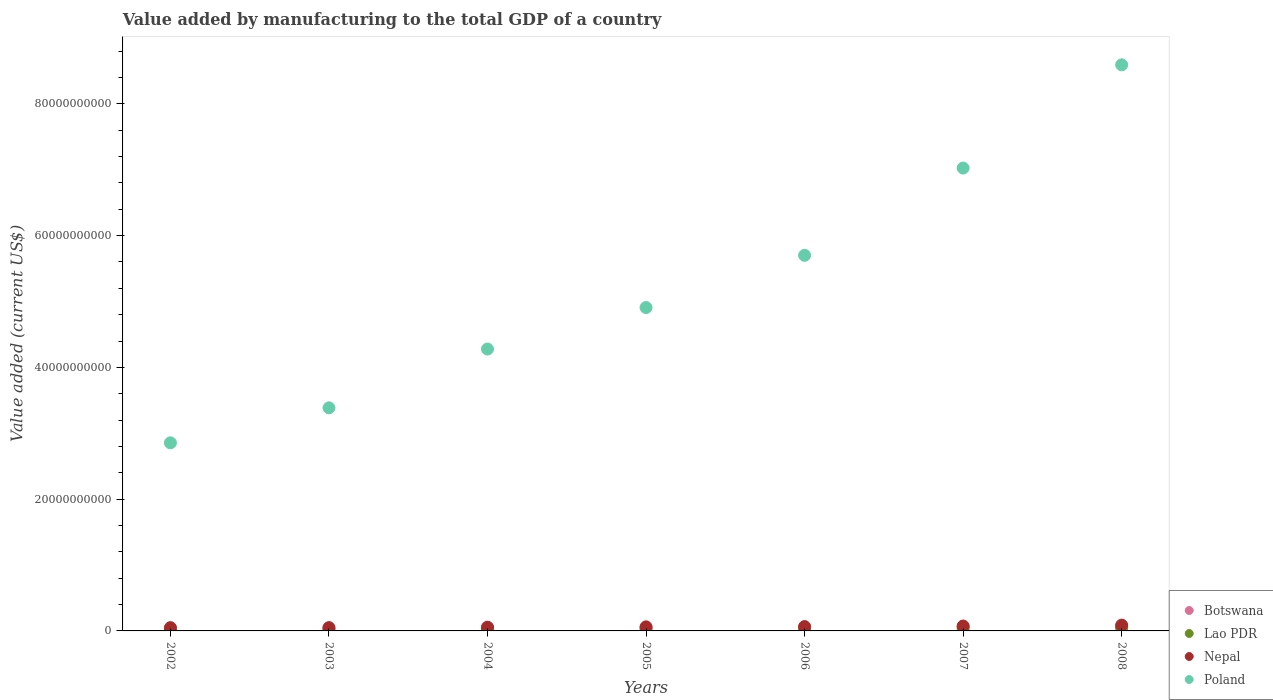How many different coloured dotlines are there?
Keep it short and to the point. 4. Is the number of dotlines equal to the number of legend labels?
Provide a short and direct response. Yes. What is the value added by manufacturing to the total GDP in Lao PDR in 2002?
Ensure brevity in your answer.  1.49e+08. Across all years, what is the maximum value added by manufacturing to the total GDP in Botswana?
Your answer should be compact. 6.85e+08. Across all years, what is the minimum value added by manufacturing to the total GDP in Nepal?
Offer a terse response. 4.97e+08. What is the total value added by manufacturing to the total GDP in Poland in the graph?
Ensure brevity in your answer.  3.67e+11. What is the difference between the value added by manufacturing to the total GDP in Lao PDR in 2002 and that in 2004?
Make the answer very short. -5.04e+07. What is the difference between the value added by manufacturing to the total GDP in Botswana in 2005 and the value added by manufacturing to the total GDP in Poland in 2007?
Your response must be concise. -6.98e+1. What is the average value added by manufacturing to the total GDP in Nepal per year?
Your response must be concise. 6.37e+08. In the year 2005, what is the difference between the value added by manufacturing to the total GDP in Botswana and value added by manufacturing to the total GDP in Nepal?
Offer a terse response. -1.28e+08. In how many years, is the value added by manufacturing to the total GDP in Nepal greater than 8000000000 US$?
Offer a very short reply. 0. What is the ratio of the value added by manufacturing to the total GDP in Nepal in 2005 to that in 2008?
Give a very brief answer. 0.7. What is the difference between the highest and the second highest value added by manufacturing to the total GDP in Lao PDR?
Your answer should be compact. 1.13e+08. What is the difference between the highest and the lowest value added by manufacturing to the total GDP in Lao PDR?
Make the answer very short. 3.08e+08. Is it the case that in every year, the sum of the value added by manufacturing to the total GDP in Botswana and value added by manufacturing to the total GDP in Lao PDR  is greater than the sum of value added by manufacturing to the total GDP in Poland and value added by manufacturing to the total GDP in Nepal?
Provide a short and direct response. No. Is it the case that in every year, the sum of the value added by manufacturing to the total GDP in Lao PDR and value added by manufacturing to the total GDP in Poland  is greater than the value added by manufacturing to the total GDP in Nepal?
Offer a terse response. Yes. Is the value added by manufacturing to the total GDP in Nepal strictly less than the value added by manufacturing to the total GDP in Lao PDR over the years?
Provide a succinct answer. No. How many years are there in the graph?
Your answer should be compact. 7. What is the difference between two consecutive major ticks on the Y-axis?
Provide a succinct answer. 2.00e+1. Does the graph contain any zero values?
Make the answer very short. No. What is the title of the graph?
Ensure brevity in your answer.  Value added by manufacturing to the total GDP of a country. Does "Kazakhstan" appear as one of the legend labels in the graph?
Provide a succinct answer. No. What is the label or title of the Y-axis?
Keep it short and to the point. Value added (current US$). What is the Value added (current US$) of Botswana in 2002?
Your answer should be compact. 3.29e+08. What is the Value added (current US$) of Lao PDR in 2002?
Offer a terse response. 1.49e+08. What is the Value added (current US$) of Nepal in 2002?
Your answer should be compact. 4.97e+08. What is the Value added (current US$) in Poland in 2002?
Your answer should be very brief. 2.85e+1. What is the Value added (current US$) in Botswana in 2003?
Provide a short and direct response. 4.29e+08. What is the Value added (current US$) of Lao PDR in 2003?
Provide a short and direct response. 1.65e+08. What is the Value added (current US$) of Nepal in 2003?
Provide a short and direct response. 4.99e+08. What is the Value added (current US$) in Poland in 2003?
Give a very brief answer. 3.39e+1. What is the Value added (current US$) in Botswana in 2004?
Offer a very short reply. 4.98e+08. What is the Value added (current US$) of Lao PDR in 2004?
Your response must be concise. 1.99e+08. What is the Value added (current US$) in Nepal in 2004?
Provide a succinct answer. 5.65e+08. What is the Value added (current US$) in Poland in 2004?
Your answer should be very brief. 4.28e+1. What is the Value added (current US$) in Botswana in 2005?
Make the answer very short. 4.92e+08. What is the Value added (current US$) in Lao PDR in 2005?
Provide a succinct answer. 2.57e+08. What is the Value added (current US$) of Nepal in 2005?
Offer a very short reply. 6.19e+08. What is the Value added (current US$) in Poland in 2005?
Make the answer very short. 4.91e+1. What is the Value added (current US$) in Botswana in 2006?
Your response must be concise. 5.35e+08. What is the Value added (current US$) in Lao PDR in 2006?
Make the answer very short. 2.73e+08. What is the Value added (current US$) in Nepal in 2006?
Offer a very short reply. 6.61e+08. What is the Value added (current US$) in Poland in 2006?
Your response must be concise. 5.70e+1. What is the Value added (current US$) of Botswana in 2007?
Give a very brief answer. 6.85e+08. What is the Value added (current US$) of Lao PDR in 2007?
Offer a terse response. 3.44e+08. What is the Value added (current US$) in Nepal in 2007?
Ensure brevity in your answer.  7.40e+08. What is the Value added (current US$) of Poland in 2007?
Keep it short and to the point. 7.03e+1. What is the Value added (current US$) in Botswana in 2008?
Your response must be concise. 6.27e+08. What is the Value added (current US$) of Lao PDR in 2008?
Provide a succinct answer. 4.56e+08. What is the Value added (current US$) of Nepal in 2008?
Give a very brief answer. 8.80e+08. What is the Value added (current US$) of Poland in 2008?
Your response must be concise. 8.59e+1. Across all years, what is the maximum Value added (current US$) of Botswana?
Your answer should be compact. 6.85e+08. Across all years, what is the maximum Value added (current US$) of Lao PDR?
Your answer should be very brief. 4.56e+08. Across all years, what is the maximum Value added (current US$) in Nepal?
Provide a short and direct response. 8.80e+08. Across all years, what is the maximum Value added (current US$) in Poland?
Offer a terse response. 8.59e+1. Across all years, what is the minimum Value added (current US$) in Botswana?
Offer a very short reply. 3.29e+08. Across all years, what is the minimum Value added (current US$) in Lao PDR?
Your answer should be compact. 1.49e+08. Across all years, what is the minimum Value added (current US$) of Nepal?
Ensure brevity in your answer.  4.97e+08. Across all years, what is the minimum Value added (current US$) in Poland?
Give a very brief answer. 2.85e+1. What is the total Value added (current US$) of Botswana in the graph?
Provide a short and direct response. 3.59e+09. What is the total Value added (current US$) in Lao PDR in the graph?
Make the answer very short. 1.84e+09. What is the total Value added (current US$) of Nepal in the graph?
Provide a succinct answer. 4.46e+09. What is the total Value added (current US$) of Poland in the graph?
Ensure brevity in your answer.  3.67e+11. What is the difference between the Value added (current US$) in Botswana in 2002 and that in 2003?
Make the answer very short. -9.91e+07. What is the difference between the Value added (current US$) in Lao PDR in 2002 and that in 2003?
Ensure brevity in your answer.  -1.67e+07. What is the difference between the Value added (current US$) of Nepal in 2002 and that in 2003?
Make the answer very short. -2.35e+06. What is the difference between the Value added (current US$) in Poland in 2002 and that in 2003?
Your response must be concise. -5.31e+09. What is the difference between the Value added (current US$) in Botswana in 2002 and that in 2004?
Ensure brevity in your answer.  -1.68e+08. What is the difference between the Value added (current US$) in Lao PDR in 2002 and that in 2004?
Provide a succinct answer. -5.04e+07. What is the difference between the Value added (current US$) in Nepal in 2002 and that in 2004?
Offer a terse response. -6.78e+07. What is the difference between the Value added (current US$) in Poland in 2002 and that in 2004?
Provide a succinct answer. -1.42e+1. What is the difference between the Value added (current US$) of Botswana in 2002 and that in 2005?
Keep it short and to the point. -1.62e+08. What is the difference between the Value added (current US$) of Lao PDR in 2002 and that in 2005?
Give a very brief answer. -1.08e+08. What is the difference between the Value added (current US$) in Nepal in 2002 and that in 2005?
Ensure brevity in your answer.  -1.22e+08. What is the difference between the Value added (current US$) of Poland in 2002 and that in 2005?
Offer a very short reply. -2.05e+1. What is the difference between the Value added (current US$) in Botswana in 2002 and that in 2006?
Give a very brief answer. -2.06e+08. What is the difference between the Value added (current US$) of Lao PDR in 2002 and that in 2006?
Offer a very short reply. -1.25e+08. What is the difference between the Value added (current US$) in Nepal in 2002 and that in 2006?
Your answer should be compact. -1.64e+08. What is the difference between the Value added (current US$) of Poland in 2002 and that in 2006?
Your answer should be compact. -2.85e+1. What is the difference between the Value added (current US$) of Botswana in 2002 and that in 2007?
Give a very brief answer. -3.56e+08. What is the difference between the Value added (current US$) of Lao PDR in 2002 and that in 2007?
Ensure brevity in your answer.  -1.95e+08. What is the difference between the Value added (current US$) in Nepal in 2002 and that in 2007?
Your answer should be compact. -2.43e+08. What is the difference between the Value added (current US$) in Poland in 2002 and that in 2007?
Offer a terse response. -4.17e+1. What is the difference between the Value added (current US$) in Botswana in 2002 and that in 2008?
Ensure brevity in your answer.  -2.97e+08. What is the difference between the Value added (current US$) in Lao PDR in 2002 and that in 2008?
Provide a short and direct response. -3.08e+08. What is the difference between the Value added (current US$) in Nepal in 2002 and that in 2008?
Your answer should be compact. -3.83e+08. What is the difference between the Value added (current US$) in Poland in 2002 and that in 2008?
Ensure brevity in your answer.  -5.74e+1. What is the difference between the Value added (current US$) of Botswana in 2003 and that in 2004?
Keep it short and to the point. -6.89e+07. What is the difference between the Value added (current US$) in Lao PDR in 2003 and that in 2004?
Provide a succinct answer. -3.37e+07. What is the difference between the Value added (current US$) of Nepal in 2003 and that in 2004?
Give a very brief answer. -6.54e+07. What is the difference between the Value added (current US$) in Poland in 2003 and that in 2004?
Keep it short and to the point. -8.92e+09. What is the difference between the Value added (current US$) in Botswana in 2003 and that in 2005?
Your answer should be compact. -6.30e+07. What is the difference between the Value added (current US$) of Lao PDR in 2003 and that in 2005?
Make the answer very short. -9.12e+07. What is the difference between the Value added (current US$) of Nepal in 2003 and that in 2005?
Provide a short and direct response. -1.20e+08. What is the difference between the Value added (current US$) of Poland in 2003 and that in 2005?
Offer a very short reply. -1.52e+1. What is the difference between the Value added (current US$) of Botswana in 2003 and that in 2006?
Your answer should be compact. -1.07e+08. What is the difference between the Value added (current US$) of Lao PDR in 2003 and that in 2006?
Make the answer very short. -1.08e+08. What is the difference between the Value added (current US$) in Nepal in 2003 and that in 2006?
Your response must be concise. -1.62e+08. What is the difference between the Value added (current US$) of Poland in 2003 and that in 2006?
Offer a very short reply. -2.31e+1. What is the difference between the Value added (current US$) in Botswana in 2003 and that in 2007?
Offer a terse response. -2.57e+08. What is the difference between the Value added (current US$) of Lao PDR in 2003 and that in 2007?
Your response must be concise. -1.79e+08. What is the difference between the Value added (current US$) of Nepal in 2003 and that in 2007?
Your response must be concise. -2.41e+08. What is the difference between the Value added (current US$) in Poland in 2003 and that in 2007?
Provide a short and direct response. -3.64e+1. What is the difference between the Value added (current US$) of Botswana in 2003 and that in 2008?
Your response must be concise. -1.98e+08. What is the difference between the Value added (current US$) of Lao PDR in 2003 and that in 2008?
Offer a terse response. -2.91e+08. What is the difference between the Value added (current US$) in Nepal in 2003 and that in 2008?
Ensure brevity in your answer.  -3.80e+08. What is the difference between the Value added (current US$) in Poland in 2003 and that in 2008?
Your answer should be very brief. -5.21e+1. What is the difference between the Value added (current US$) of Botswana in 2004 and that in 2005?
Offer a terse response. 5.97e+06. What is the difference between the Value added (current US$) of Lao PDR in 2004 and that in 2005?
Ensure brevity in your answer.  -5.75e+07. What is the difference between the Value added (current US$) of Nepal in 2004 and that in 2005?
Make the answer very short. -5.44e+07. What is the difference between the Value added (current US$) of Poland in 2004 and that in 2005?
Provide a succinct answer. -6.30e+09. What is the difference between the Value added (current US$) of Botswana in 2004 and that in 2006?
Your answer should be very brief. -3.76e+07. What is the difference between the Value added (current US$) of Lao PDR in 2004 and that in 2006?
Provide a short and direct response. -7.44e+07. What is the difference between the Value added (current US$) in Nepal in 2004 and that in 2006?
Your response must be concise. -9.67e+07. What is the difference between the Value added (current US$) of Poland in 2004 and that in 2006?
Your answer should be very brief. -1.42e+1. What is the difference between the Value added (current US$) in Botswana in 2004 and that in 2007?
Make the answer very short. -1.88e+08. What is the difference between the Value added (current US$) in Lao PDR in 2004 and that in 2007?
Give a very brief answer. -1.45e+08. What is the difference between the Value added (current US$) of Nepal in 2004 and that in 2007?
Your answer should be compact. -1.75e+08. What is the difference between the Value added (current US$) of Poland in 2004 and that in 2007?
Provide a succinct answer. -2.75e+1. What is the difference between the Value added (current US$) of Botswana in 2004 and that in 2008?
Your answer should be very brief. -1.29e+08. What is the difference between the Value added (current US$) in Lao PDR in 2004 and that in 2008?
Your answer should be very brief. -2.57e+08. What is the difference between the Value added (current US$) in Nepal in 2004 and that in 2008?
Your answer should be very brief. -3.15e+08. What is the difference between the Value added (current US$) in Poland in 2004 and that in 2008?
Provide a short and direct response. -4.31e+1. What is the difference between the Value added (current US$) of Botswana in 2005 and that in 2006?
Make the answer very short. -4.35e+07. What is the difference between the Value added (current US$) in Lao PDR in 2005 and that in 2006?
Ensure brevity in your answer.  -1.69e+07. What is the difference between the Value added (current US$) in Nepal in 2005 and that in 2006?
Provide a short and direct response. -4.23e+07. What is the difference between the Value added (current US$) in Poland in 2005 and that in 2006?
Make the answer very short. -7.93e+09. What is the difference between the Value added (current US$) of Botswana in 2005 and that in 2007?
Your response must be concise. -1.94e+08. What is the difference between the Value added (current US$) of Lao PDR in 2005 and that in 2007?
Your answer should be very brief. -8.74e+07. What is the difference between the Value added (current US$) of Nepal in 2005 and that in 2007?
Keep it short and to the point. -1.21e+08. What is the difference between the Value added (current US$) in Poland in 2005 and that in 2007?
Provide a short and direct response. -2.12e+1. What is the difference between the Value added (current US$) in Botswana in 2005 and that in 2008?
Give a very brief answer. -1.35e+08. What is the difference between the Value added (current US$) in Lao PDR in 2005 and that in 2008?
Your response must be concise. -2.00e+08. What is the difference between the Value added (current US$) in Nepal in 2005 and that in 2008?
Offer a very short reply. -2.60e+08. What is the difference between the Value added (current US$) of Poland in 2005 and that in 2008?
Make the answer very short. -3.68e+1. What is the difference between the Value added (current US$) in Botswana in 2006 and that in 2007?
Ensure brevity in your answer.  -1.50e+08. What is the difference between the Value added (current US$) in Lao PDR in 2006 and that in 2007?
Keep it short and to the point. -7.05e+07. What is the difference between the Value added (current US$) in Nepal in 2006 and that in 2007?
Your answer should be compact. -7.87e+07. What is the difference between the Value added (current US$) in Poland in 2006 and that in 2007?
Give a very brief answer. -1.32e+1. What is the difference between the Value added (current US$) in Botswana in 2006 and that in 2008?
Offer a terse response. -9.17e+07. What is the difference between the Value added (current US$) in Lao PDR in 2006 and that in 2008?
Give a very brief answer. -1.83e+08. What is the difference between the Value added (current US$) in Nepal in 2006 and that in 2008?
Your answer should be very brief. -2.18e+08. What is the difference between the Value added (current US$) of Poland in 2006 and that in 2008?
Your answer should be very brief. -2.89e+1. What is the difference between the Value added (current US$) of Botswana in 2007 and that in 2008?
Give a very brief answer. 5.85e+07. What is the difference between the Value added (current US$) of Lao PDR in 2007 and that in 2008?
Keep it short and to the point. -1.13e+08. What is the difference between the Value added (current US$) in Nepal in 2007 and that in 2008?
Your answer should be compact. -1.39e+08. What is the difference between the Value added (current US$) in Poland in 2007 and that in 2008?
Make the answer very short. -1.57e+1. What is the difference between the Value added (current US$) in Botswana in 2002 and the Value added (current US$) in Lao PDR in 2003?
Your answer should be compact. 1.64e+08. What is the difference between the Value added (current US$) of Botswana in 2002 and the Value added (current US$) of Nepal in 2003?
Offer a very short reply. -1.70e+08. What is the difference between the Value added (current US$) of Botswana in 2002 and the Value added (current US$) of Poland in 2003?
Provide a succinct answer. -3.35e+1. What is the difference between the Value added (current US$) in Lao PDR in 2002 and the Value added (current US$) in Nepal in 2003?
Your answer should be very brief. -3.51e+08. What is the difference between the Value added (current US$) in Lao PDR in 2002 and the Value added (current US$) in Poland in 2003?
Keep it short and to the point. -3.37e+1. What is the difference between the Value added (current US$) in Nepal in 2002 and the Value added (current US$) in Poland in 2003?
Your response must be concise. -3.34e+1. What is the difference between the Value added (current US$) of Botswana in 2002 and the Value added (current US$) of Lao PDR in 2004?
Your answer should be compact. 1.30e+08. What is the difference between the Value added (current US$) of Botswana in 2002 and the Value added (current US$) of Nepal in 2004?
Ensure brevity in your answer.  -2.35e+08. What is the difference between the Value added (current US$) in Botswana in 2002 and the Value added (current US$) in Poland in 2004?
Ensure brevity in your answer.  -4.25e+1. What is the difference between the Value added (current US$) of Lao PDR in 2002 and the Value added (current US$) of Nepal in 2004?
Give a very brief answer. -4.16e+08. What is the difference between the Value added (current US$) in Lao PDR in 2002 and the Value added (current US$) in Poland in 2004?
Give a very brief answer. -4.26e+1. What is the difference between the Value added (current US$) in Nepal in 2002 and the Value added (current US$) in Poland in 2004?
Keep it short and to the point. -4.23e+1. What is the difference between the Value added (current US$) of Botswana in 2002 and the Value added (current US$) of Lao PDR in 2005?
Offer a very short reply. 7.28e+07. What is the difference between the Value added (current US$) in Botswana in 2002 and the Value added (current US$) in Nepal in 2005?
Offer a terse response. -2.90e+08. What is the difference between the Value added (current US$) of Botswana in 2002 and the Value added (current US$) of Poland in 2005?
Offer a terse response. -4.88e+1. What is the difference between the Value added (current US$) in Lao PDR in 2002 and the Value added (current US$) in Nepal in 2005?
Make the answer very short. -4.70e+08. What is the difference between the Value added (current US$) of Lao PDR in 2002 and the Value added (current US$) of Poland in 2005?
Offer a terse response. -4.89e+1. What is the difference between the Value added (current US$) in Nepal in 2002 and the Value added (current US$) in Poland in 2005?
Ensure brevity in your answer.  -4.86e+1. What is the difference between the Value added (current US$) of Botswana in 2002 and the Value added (current US$) of Lao PDR in 2006?
Make the answer very short. 5.60e+07. What is the difference between the Value added (current US$) in Botswana in 2002 and the Value added (current US$) in Nepal in 2006?
Provide a succinct answer. -3.32e+08. What is the difference between the Value added (current US$) in Botswana in 2002 and the Value added (current US$) in Poland in 2006?
Provide a short and direct response. -5.67e+1. What is the difference between the Value added (current US$) in Lao PDR in 2002 and the Value added (current US$) in Nepal in 2006?
Provide a short and direct response. -5.13e+08. What is the difference between the Value added (current US$) of Lao PDR in 2002 and the Value added (current US$) of Poland in 2006?
Ensure brevity in your answer.  -5.69e+1. What is the difference between the Value added (current US$) of Nepal in 2002 and the Value added (current US$) of Poland in 2006?
Give a very brief answer. -5.65e+1. What is the difference between the Value added (current US$) of Botswana in 2002 and the Value added (current US$) of Lao PDR in 2007?
Provide a succinct answer. -1.45e+07. What is the difference between the Value added (current US$) of Botswana in 2002 and the Value added (current US$) of Nepal in 2007?
Ensure brevity in your answer.  -4.11e+08. What is the difference between the Value added (current US$) in Botswana in 2002 and the Value added (current US$) in Poland in 2007?
Provide a short and direct response. -6.99e+1. What is the difference between the Value added (current US$) of Lao PDR in 2002 and the Value added (current US$) of Nepal in 2007?
Offer a terse response. -5.91e+08. What is the difference between the Value added (current US$) of Lao PDR in 2002 and the Value added (current US$) of Poland in 2007?
Keep it short and to the point. -7.01e+1. What is the difference between the Value added (current US$) in Nepal in 2002 and the Value added (current US$) in Poland in 2007?
Keep it short and to the point. -6.98e+1. What is the difference between the Value added (current US$) in Botswana in 2002 and the Value added (current US$) in Lao PDR in 2008?
Your response must be concise. -1.27e+08. What is the difference between the Value added (current US$) in Botswana in 2002 and the Value added (current US$) in Nepal in 2008?
Keep it short and to the point. -5.50e+08. What is the difference between the Value added (current US$) in Botswana in 2002 and the Value added (current US$) in Poland in 2008?
Keep it short and to the point. -8.56e+1. What is the difference between the Value added (current US$) of Lao PDR in 2002 and the Value added (current US$) of Nepal in 2008?
Offer a terse response. -7.31e+08. What is the difference between the Value added (current US$) in Lao PDR in 2002 and the Value added (current US$) in Poland in 2008?
Your answer should be compact. -8.58e+1. What is the difference between the Value added (current US$) of Nepal in 2002 and the Value added (current US$) of Poland in 2008?
Ensure brevity in your answer.  -8.54e+1. What is the difference between the Value added (current US$) in Botswana in 2003 and the Value added (current US$) in Lao PDR in 2004?
Provide a short and direct response. 2.29e+08. What is the difference between the Value added (current US$) in Botswana in 2003 and the Value added (current US$) in Nepal in 2004?
Your answer should be compact. -1.36e+08. What is the difference between the Value added (current US$) in Botswana in 2003 and the Value added (current US$) in Poland in 2004?
Your response must be concise. -4.24e+1. What is the difference between the Value added (current US$) of Lao PDR in 2003 and the Value added (current US$) of Nepal in 2004?
Your answer should be very brief. -3.99e+08. What is the difference between the Value added (current US$) of Lao PDR in 2003 and the Value added (current US$) of Poland in 2004?
Your response must be concise. -4.26e+1. What is the difference between the Value added (current US$) of Nepal in 2003 and the Value added (current US$) of Poland in 2004?
Make the answer very short. -4.23e+1. What is the difference between the Value added (current US$) of Botswana in 2003 and the Value added (current US$) of Lao PDR in 2005?
Offer a very short reply. 1.72e+08. What is the difference between the Value added (current US$) in Botswana in 2003 and the Value added (current US$) in Nepal in 2005?
Your answer should be very brief. -1.91e+08. What is the difference between the Value added (current US$) in Botswana in 2003 and the Value added (current US$) in Poland in 2005?
Provide a succinct answer. -4.87e+1. What is the difference between the Value added (current US$) of Lao PDR in 2003 and the Value added (current US$) of Nepal in 2005?
Provide a succinct answer. -4.54e+08. What is the difference between the Value added (current US$) of Lao PDR in 2003 and the Value added (current US$) of Poland in 2005?
Give a very brief answer. -4.89e+1. What is the difference between the Value added (current US$) in Nepal in 2003 and the Value added (current US$) in Poland in 2005?
Provide a succinct answer. -4.86e+1. What is the difference between the Value added (current US$) in Botswana in 2003 and the Value added (current US$) in Lao PDR in 2006?
Provide a succinct answer. 1.55e+08. What is the difference between the Value added (current US$) in Botswana in 2003 and the Value added (current US$) in Nepal in 2006?
Ensure brevity in your answer.  -2.33e+08. What is the difference between the Value added (current US$) in Botswana in 2003 and the Value added (current US$) in Poland in 2006?
Provide a short and direct response. -5.66e+1. What is the difference between the Value added (current US$) in Lao PDR in 2003 and the Value added (current US$) in Nepal in 2006?
Offer a very short reply. -4.96e+08. What is the difference between the Value added (current US$) in Lao PDR in 2003 and the Value added (current US$) in Poland in 2006?
Your response must be concise. -5.68e+1. What is the difference between the Value added (current US$) of Nepal in 2003 and the Value added (current US$) of Poland in 2006?
Provide a succinct answer. -5.65e+1. What is the difference between the Value added (current US$) in Botswana in 2003 and the Value added (current US$) in Lao PDR in 2007?
Offer a very short reply. 8.46e+07. What is the difference between the Value added (current US$) in Botswana in 2003 and the Value added (current US$) in Nepal in 2007?
Keep it short and to the point. -3.12e+08. What is the difference between the Value added (current US$) in Botswana in 2003 and the Value added (current US$) in Poland in 2007?
Provide a short and direct response. -6.98e+1. What is the difference between the Value added (current US$) in Lao PDR in 2003 and the Value added (current US$) in Nepal in 2007?
Give a very brief answer. -5.75e+08. What is the difference between the Value added (current US$) of Lao PDR in 2003 and the Value added (current US$) of Poland in 2007?
Ensure brevity in your answer.  -7.01e+1. What is the difference between the Value added (current US$) in Nepal in 2003 and the Value added (current US$) in Poland in 2007?
Offer a terse response. -6.98e+1. What is the difference between the Value added (current US$) of Botswana in 2003 and the Value added (current US$) of Lao PDR in 2008?
Give a very brief answer. -2.79e+07. What is the difference between the Value added (current US$) of Botswana in 2003 and the Value added (current US$) of Nepal in 2008?
Keep it short and to the point. -4.51e+08. What is the difference between the Value added (current US$) of Botswana in 2003 and the Value added (current US$) of Poland in 2008?
Keep it short and to the point. -8.55e+1. What is the difference between the Value added (current US$) of Lao PDR in 2003 and the Value added (current US$) of Nepal in 2008?
Provide a short and direct response. -7.14e+08. What is the difference between the Value added (current US$) of Lao PDR in 2003 and the Value added (current US$) of Poland in 2008?
Provide a short and direct response. -8.58e+1. What is the difference between the Value added (current US$) of Nepal in 2003 and the Value added (current US$) of Poland in 2008?
Your answer should be compact. -8.54e+1. What is the difference between the Value added (current US$) of Botswana in 2004 and the Value added (current US$) of Lao PDR in 2005?
Offer a very short reply. 2.41e+08. What is the difference between the Value added (current US$) of Botswana in 2004 and the Value added (current US$) of Nepal in 2005?
Your response must be concise. -1.22e+08. What is the difference between the Value added (current US$) of Botswana in 2004 and the Value added (current US$) of Poland in 2005?
Make the answer very short. -4.86e+1. What is the difference between the Value added (current US$) in Lao PDR in 2004 and the Value added (current US$) in Nepal in 2005?
Give a very brief answer. -4.20e+08. What is the difference between the Value added (current US$) of Lao PDR in 2004 and the Value added (current US$) of Poland in 2005?
Give a very brief answer. -4.89e+1. What is the difference between the Value added (current US$) of Nepal in 2004 and the Value added (current US$) of Poland in 2005?
Provide a succinct answer. -4.85e+1. What is the difference between the Value added (current US$) in Botswana in 2004 and the Value added (current US$) in Lao PDR in 2006?
Provide a short and direct response. 2.24e+08. What is the difference between the Value added (current US$) of Botswana in 2004 and the Value added (current US$) of Nepal in 2006?
Make the answer very short. -1.64e+08. What is the difference between the Value added (current US$) of Botswana in 2004 and the Value added (current US$) of Poland in 2006?
Give a very brief answer. -5.65e+1. What is the difference between the Value added (current US$) of Lao PDR in 2004 and the Value added (current US$) of Nepal in 2006?
Keep it short and to the point. -4.62e+08. What is the difference between the Value added (current US$) in Lao PDR in 2004 and the Value added (current US$) in Poland in 2006?
Your answer should be very brief. -5.68e+1. What is the difference between the Value added (current US$) of Nepal in 2004 and the Value added (current US$) of Poland in 2006?
Ensure brevity in your answer.  -5.64e+1. What is the difference between the Value added (current US$) of Botswana in 2004 and the Value added (current US$) of Lao PDR in 2007?
Offer a very short reply. 1.54e+08. What is the difference between the Value added (current US$) in Botswana in 2004 and the Value added (current US$) in Nepal in 2007?
Provide a short and direct response. -2.43e+08. What is the difference between the Value added (current US$) of Botswana in 2004 and the Value added (current US$) of Poland in 2007?
Make the answer very short. -6.98e+1. What is the difference between the Value added (current US$) in Lao PDR in 2004 and the Value added (current US$) in Nepal in 2007?
Your answer should be compact. -5.41e+08. What is the difference between the Value added (current US$) of Lao PDR in 2004 and the Value added (current US$) of Poland in 2007?
Keep it short and to the point. -7.01e+1. What is the difference between the Value added (current US$) of Nepal in 2004 and the Value added (current US$) of Poland in 2007?
Your answer should be compact. -6.97e+1. What is the difference between the Value added (current US$) of Botswana in 2004 and the Value added (current US$) of Lao PDR in 2008?
Provide a short and direct response. 4.10e+07. What is the difference between the Value added (current US$) in Botswana in 2004 and the Value added (current US$) in Nepal in 2008?
Make the answer very short. -3.82e+08. What is the difference between the Value added (current US$) of Botswana in 2004 and the Value added (current US$) of Poland in 2008?
Keep it short and to the point. -8.54e+1. What is the difference between the Value added (current US$) of Lao PDR in 2004 and the Value added (current US$) of Nepal in 2008?
Make the answer very short. -6.80e+08. What is the difference between the Value added (current US$) in Lao PDR in 2004 and the Value added (current US$) in Poland in 2008?
Keep it short and to the point. -8.57e+1. What is the difference between the Value added (current US$) of Nepal in 2004 and the Value added (current US$) of Poland in 2008?
Offer a terse response. -8.54e+1. What is the difference between the Value added (current US$) in Botswana in 2005 and the Value added (current US$) in Lao PDR in 2006?
Your answer should be compact. 2.18e+08. What is the difference between the Value added (current US$) in Botswana in 2005 and the Value added (current US$) in Nepal in 2006?
Keep it short and to the point. -1.70e+08. What is the difference between the Value added (current US$) of Botswana in 2005 and the Value added (current US$) of Poland in 2006?
Give a very brief answer. -5.65e+1. What is the difference between the Value added (current US$) of Lao PDR in 2005 and the Value added (current US$) of Nepal in 2006?
Make the answer very short. -4.05e+08. What is the difference between the Value added (current US$) in Lao PDR in 2005 and the Value added (current US$) in Poland in 2006?
Provide a short and direct response. -5.68e+1. What is the difference between the Value added (current US$) of Nepal in 2005 and the Value added (current US$) of Poland in 2006?
Give a very brief answer. -5.64e+1. What is the difference between the Value added (current US$) of Botswana in 2005 and the Value added (current US$) of Lao PDR in 2007?
Your response must be concise. 1.48e+08. What is the difference between the Value added (current US$) in Botswana in 2005 and the Value added (current US$) in Nepal in 2007?
Give a very brief answer. -2.49e+08. What is the difference between the Value added (current US$) of Botswana in 2005 and the Value added (current US$) of Poland in 2007?
Your answer should be very brief. -6.98e+1. What is the difference between the Value added (current US$) of Lao PDR in 2005 and the Value added (current US$) of Nepal in 2007?
Keep it short and to the point. -4.84e+08. What is the difference between the Value added (current US$) in Lao PDR in 2005 and the Value added (current US$) in Poland in 2007?
Your answer should be very brief. -7.00e+1. What is the difference between the Value added (current US$) in Nepal in 2005 and the Value added (current US$) in Poland in 2007?
Provide a short and direct response. -6.96e+1. What is the difference between the Value added (current US$) in Botswana in 2005 and the Value added (current US$) in Lao PDR in 2008?
Offer a very short reply. 3.51e+07. What is the difference between the Value added (current US$) of Botswana in 2005 and the Value added (current US$) of Nepal in 2008?
Make the answer very short. -3.88e+08. What is the difference between the Value added (current US$) of Botswana in 2005 and the Value added (current US$) of Poland in 2008?
Offer a very short reply. -8.54e+1. What is the difference between the Value added (current US$) of Lao PDR in 2005 and the Value added (current US$) of Nepal in 2008?
Give a very brief answer. -6.23e+08. What is the difference between the Value added (current US$) of Lao PDR in 2005 and the Value added (current US$) of Poland in 2008?
Your answer should be very brief. -8.57e+1. What is the difference between the Value added (current US$) of Nepal in 2005 and the Value added (current US$) of Poland in 2008?
Offer a very short reply. -8.53e+1. What is the difference between the Value added (current US$) in Botswana in 2006 and the Value added (current US$) in Lao PDR in 2007?
Your answer should be compact. 1.91e+08. What is the difference between the Value added (current US$) in Botswana in 2006 and the Value added (current US$) in Nepal in 2007?
Provide a short and direct response. -2.05e+08. What is the difference between the Value added (current US$) in Botswana in 2006 and the Value added (current US$) in Poland in 2007?
Your answer should be very brief. -6.97e+1. What is the difference between the Value added (current US$) of Lao PDR in 2006 and the Value added (current US$) of Nepal in 2007?
Provide a succinct answer. -4.67e+08. What is the difference between the Value added (current US$) of Lao PDR in 2006 and the Value added (current US$) of Poland in 2007?
Provide a succinct answer. -7.00e+1. What is the difference between the Value added (current US$) of Nepal in 2006 and the Value added (current US$) of Poland in 2007?
Ensure brevity in your answer.  -6.96e+1. What is the difference between the Value added (current US$) in Botswana in 2006 and the Value added (current US$) in Lao PDR in 2008?
Ensure brevity in your answer.  7.86e+07. What is the difference between the Value added (current US$) of Botswana in 2006 and the Value added (current US$) of Nepal in 2008?
Keep it short and to the point. -3.44e+08. What is the difference between the Value added (current US$) of Botswana in 2006 and the Value added (current US$) of Poland in 2008?
Ensure brevity in your answer.  -8.54e+1. What is the difference between the Value added (current US$) of Lao PDR in 2006 and the Value added (current US$) of Nepal in 2008?
Your answer should be very brief. -6.06e+08. What is the difference between the Value added (current US$) of Lao PDR in 2006 and the Value added (current US$) of Poland in 2008?
Your answer should be compact. -8.56e+1. What is the difference between the Value added (current US$) in Nepal in 2006 and the Value added (current US$) in Poland in 2008?
Your answer should be compact. -8.53e+1. What is the difference between the Value added (current US$) of Botswana in 2007 and the Value added (current US$) of Lao PDR in 2008?
Provide a succinct answer. 2.29e+08. What is the difference between the Value added (current US$) of Botswana in 2007 and the Value added (current US$) of Nepal in 2008?
Make the answer very short. -1.94e+08. What is the difference between the Value added (current US$) of Botswana in 2007 and the Value added (current US$) of Poland in 2008?
Ensure brevity in your answer.  -8.52e+1. What is the difference between the Value added (current US$) in Lao PDR in 2007 and the Value added (current US$) in Nepal in 2008?
Your answer should be compact. -5.36e+08. What is the difference between the Value added (current US$) in Lao PDR in 2007 and the Value added (current US$) in Poland in 2008?
Provide a succinct answer. -8.56e+1. What is the difference between the Value added (current US$) of Nepal in 2007 and the Value added (current US$) of Poland in 2008?
Keep it short and to the point. -8.52e+1. What is the average Value added (current US$) in Botswana per year?
Provide a short and direct response. 5.13e+08. What is the average Value added (current US$) in Lao PDR per year?
Give a very brief answer. 2.63e+08. What is the average Value added (current US$) of Nepal per year?
Your response must be concise. 6.37e+08. What is the average Value added (current US$) of Poland per year?
Ensure brevity in your answer.  5.25e+1. In the year 2002, what is the difference between the Value added (current US$) of Botswana and Value added (current US$) of Lao PDR?
Your answer should be compact. 1.81e+08. In the year 2002, what is the difference between the Value added (current US$) in Botswana and Value added (current US$) in Nepal?
Offer a terse response. -1.68e+08. In the year 2002, what is the difference between the Value added (current US$) in Botswana and Value added (current US$) in Poland?
Your answer should be very brief. -2.82e+1. In the year 2002, what is the difference between the Value added (current US$) in Lao PDR and Value added (current US$) in Nepal?
Make the answer very short. -3.48e+08. In the year 2002, what is the difference between the Value added (current US$) of Lao PDR and Value added (current US$) of Poland?
Your answer should be compact. -2.84e+1. In the year 2002, what is the difference between the Value added (current US$) of Nepal and Value added (current US$) of Poland?
Your response must be concise. -2.81e+1. In the year 2003, what is the difference between the Value added (current US$) of Botswana and Value added (current US$) of Lao PDR?
Ensure brevity in your answer.  2.63e+08. In the year 2003, what is the difference between the Value added (current US$) in Botswana and Value added (current US$) in Nepal?
Ensure brevity in your answer.  -7.08e+07. In the year 2003, what is the difference between the Value added (current US$) in Botswana and Value added (current US$) in Poland?
Offer a very short reply. -3.34e+1. In the year 2003, what is the difference between the Value added (current US$) in Lao PDR and Value added (current US$) in Nepal?
Provide a short and direct response. -3.34e+08. In the year 2003, what is the difference between the Value added (current US$) in Lao PDR and Value added (current US$) in Poland?
Provide a succinct answer. -3.37e+1. In the year 2003, what is the difference between the Value added (current US$) in Nepal and Value added (current US$) in Poland?
Your answer should be very brief. -3.34e+1. In the year 2004, what is the difference between the Value added (current US$) of Botswana and Value added (current US$) of Lao PDR?
Keep it short and to the point. 2.98e+08. In the year 2004, what is the difference between the Value added (current US$) of Botswana and Value added (current US$) of Nepal?
Ensure brevity in your answer.  -6.72e+07. In the year 2004, what is the difference between the Value added (current US$) in Botswana and Value added (current US$) in Poland?
Keep it short and to the point. -4.23e+1. In the year 2004, what is the difference between the Value added (current US$) in Lao PDR and Value added (current US$) in Nepal?
Provide a succinct answer. -3.66e+08. In the year 2004, what is the difference between the Value added (current US$) of Lao PDR and Value added (current US$) of Poland?
Make the answer very short. -4.26e+1. In the year 2004, what is the difference between the Value added (current US$) in Nepal and Value added (current US$) in Poland?
Provide a succinct answer. -4.22e+1. In the year 2005, what is the difference between the Value added (current US$) in Botswana and Value added (current US$) in Lao PDR?
Make the answer very short. 2.35e+08. In the year 2005, what is the difference between the Value added (current US$) in Botswana and Value added (current US$) in Nepal?
Provide a succinct answer. -1.28e+08. In the year 2005, what is the difference between the Value added (current US$) of Botswana and Value added (current US$) of Poland?
Offer a terse response. -4.86e+1. In the year 2005, what is the difference between the Value added (current US$) in Lao PDR and Value added (current US$) in Nepal?
Ensure brevity in your answer.  -3.63e+08. In the year 2005, what is the difference between the Value added (current US$) in Lao PDR and Value added (current US$) in Poland?
Offer a terse response. -4.88e+1. In the year 2005, what is the difference between the Value added (current US$) in Nepal and Value added (current US$) in Poland?
Ensure brevity in your answer.  -4.85e+1. In the year 2006, what is the difference between the Value added (current US$) of Botswana and Value added (current US$) of Lao PDR?
Ensure brevity in your answer.  2.62e+08. In the year 2006, what is the difference between the Value added (current US$) in Botswana and Value added (current US$) in Nepal?
Your answer should be compact. -1.26e+08. In the year 2006, what is the difference between the Value added (current US$) in Botswana and Value added (current US$) in Poland?
Offer a very short reply. -5.65e+1. In the year 2006, what is the difference between the Value added (current US$) of Lao PDR and Value added (current US$) of Nepal?
Your response must be concise. -3.88e+08. In the year 2006, what is the difference between the Value added (current US$) in Lao PDR and Value added (current US$) in Poland?
Your answer should be very brief. -5.67e+1. In the year 2006, what is the difference between the Value added (current US$) of Nepal and Value added (current US$) of Poland?
Your answer should be compact. -5.63e+1. In the year 2007, what is the difference between the Value added (current US$) in Botswana and Value added (current US$) in Lao PDR?
Offer a very short reply. 3.41e+08. In the year 2007, what is the difference between the Value added (current US$) of Botswana and Value added (current US$) of Nepal?
Keep it short and to the point. -5.49e+07. In the year 2007, what is the difference between the Value added (current US$) of Botswana and Value added (current US$) of Poland?
Your response must be concise. -6.96e+1. In the year 2007, what is the difference between the Value added (current US$) of Lao PDR and Value added (current US$) of Nepal?
Your response must be concise. -3.96e+08. In the year 2007, what is the difference between the Value added (current US$) in Lao PDR and Value added (current US$) in Poland?
Offer a terse response. -6.99e+1. In the year 2007, what is the difference between the Value added (current US$) of Nepal and Value added (current US$) of Poland?
Ensure brevity in your answer.  -6.95e+1. In the year 2008, what is the difference between the Value added (current US$) of Botswana and Value added (current US$) of Lao PDR?
Offer a terse response. 1.70e+08. In the year 2008, what is the difference between the Value added (current US$) in Botswana and Value added (current US$) in Nepal?
Provide a succinct answer. -2.53e+08. In the year 2008, what is the difference between the Value added (current US$) of Botswana and Value added (current US$) of Poland?
Offer a terse response. -8.53e+1. In the year 2008, what is the difference between the Value added (current US$) in Lao PDR and Value added (current US$) in Nepal?
Your response must be concise. -4.23e+08. In the year 2008, what is the difference between the Value added (current US$) of Lao PDR and Value added (current US$) of Poland?
Ensure brevity in your answer.  -8.55e+1. In the year 2008, what is the difference between the Value added (current US$) of Nepal and Value added (current US$) of Poland?
Keep it short and to the point. -8.50e+1. What is the ratio of the Value added (current US$) of Botswana in 2002 to that in 2003?
Your answer should be compact. 0.77. What is the ratio of the Value added (current US$) of Lao PDR in 2002 to that in 2003?
Give a very brief answer. 0.9. What is the ratio of the Value added (current US$) in Poland in 2002 to that in 2003?
Make the answer very short. 0.84. What is the ratio of the Value added (current US$) in Botswana in 2002 to that in 2004?
Offer a very short reply. 0.66. What is the ratio of the Value added (current US$) of Lao PDR in 2002 to that in 2004?
Your answer should be compact. 0.75. What is the ratio of the Value added (current US$) of Nepal in 2002 to that in 2004?
Your answer should be compact. 0.88. What is the ratio of the Value added (current US$) of Poland in 2002 to that in 2004?
Your answer should be compact. 0.67. What is the ratio of the Value added (current US$) of Botswana in 2002 to that in 2005?
Keep it short and to the point. 0.67. What is the ratio of the Value added (current US$) of Lao PDR in 2002 to that in 2005?
Offer a terse response. 0.58. What is the ratio of the Value added (current US$) of Nepal in 2002 to that in 2005?
Offer a very short reply. 0.8. What is the ratio of the Value added (current US$) of Poland in 2002 to that in 2005?
Your answer should be compact. 0.58. What is the ratio of the Value added (current US$) in Botswana in 2002 to that in 2006?
Your answer should be very brief. 0.62. What is the ratio of the Value added (current US$) of Lao PDR in 2002 to that in 2006?
Your response must be concise. 0.54. What is the ratio of the Value added (current US$) of Nepal in 2002 to that in 2006?
Provide a succinct answer. 0.75. What is the ratio of the Value added (current US$) of Poland in 2002 to that in 2006?
Ensure brevity in your answer.  0.5. What is the ratio of the Value added (current US$) of Botswana in 2002 to that in 2007?
Keep it short and to the point. 0.48. What is the ratio of the Value added (current US$) of Lao PDR in 2002 to that in 2007?
Your answer should be very brief. 0.43. What is the ratio of the Value added (current US$) of Nepal in 2002 to that in 2007?
Provide a succinct answer. 0.67. What is the ratio of the Value added (current US$) in Poland in 2002 to that in 2007?
Provide a succinct answer. 0.41. What is the ratio of the Value added (current US$) of Botswana in 2002 to that in 2008?
Make the answer very short. 0.53. What is the ratio of the Value added (current US$) in Lao PDR in 2002 to that in 2008?
Your response must be concise. 0.33. What is the ratio of the Value added (current US$) of Nepal in 2002 to that in 2008?
Provide a succinct answer. 0.56. What is the ratio of the Value added (current US$) of Poland in 2002 to that in 2008?
Offer a terse response. 0.33. What is the ratio of the Value added (current US$) of Botswana in 2003 to that in 2004?
Give a very brief answer. 0.86. What is the ratio of the Value added (current US$) in Lao PDR in 2003 to that in 2004?
Offer a very short reply. 0.83. What is the ratio of the Value added (current US$) of Nepal in 2003 to that in 2004?
Your answer should be compact. 0.88. What is the ratio of the Value added (current US$) of Poland in 2003 to that in 2004?
Your response must be concise. 0.79. What is the ratio of the Value added (current US$) in Botswana in 2003 to that in 2005?
Make the answer very short. 0.87. What is the ratio of the Value added (current US$) of Lao PDR in 2003 to that in 2005?
Give a very brief answer. 0.64. What is the ratio of the Value added (current US$) in Nepal in 2003 to that in 2005?
Provide a short and direct response. 0.81. What is the ratio of the Value added (current US$) of Poland in 2003 to that in 2005?
Your answer should be very brief. 0.69. What is the ratio of the Value added (current US$) of Botswana in 2003 to that in 2006?
Provide a succinct answer. 0.8. What is the ratio of the Value added (current US$) of Lao PDR in 2003 to that in 2006?
Give a very brief answer. 0.6. What is the ratio of the Value added (current US$) of Nepal in 2003 to that in 2006?
Provide a short and direct response. 0.75. What is the ratio of the Value added (current US$) in Poland in 2003 to that in 2006?
Offer a very short reply. 0.59. What is the ratio of the Value added (current US$) in Botswana in 2003 to that in 2007?
Keep it short and to the point. 0.63. What is the ratio of the Value added (current US$) of Lao PDR in 2003 to that in 2007?
Provide a succinct answer. 0.48. What is the ratio of the Value added (current US$) in Nepal in 2003 to that in 2007?
Make the answer very short. 0.67. What is the ratio of the Value added (current US$) of Poland in 2003 to that in 2007?
Offer a terse response. 0.48. What is the ratio of the Value added (current US$) of Botswana in 2003 to that in 2008?
Your response must be concise. 0.68. What is the ratio of the Value added (current US$) in Lao PDR in 2003 to that in 2008?
Your answer should be compact. 0.36. What is the ratio of the Value added (current US$) in Nepal in 2003 to that in 2008?
Give a very brief answer. 0.57. What is the ratio of the Value added (current US$) of Poland in 2003 to that in 2008?
Give a very brief answer. 0.39. What is the ratio of the Value added (current US$) of Botswana in 2004 to that in 2005?
Your answer should be compact. 1.01. What is the ratio of the Value added (current US$) in Lao PDR in 2004 to that in 2005?
Provide a succinct answer. 0.78. What is the ratio of the Value added (current US$) of Nepal in 2004 to that in 2005?
Make the answer very short. 0.91. What is the ratio of the Value added (current US$) in Poland in 2004 to that in 2005?
Your answer should be compact. 0.87. What is the ratio of the Value added (current US$) in Botswana in 2004 to that in 2006?
Give a very brief answer. 0.93. What is the ratio of the Value added (current US$) of Lao PDR in 2004 to that in 2006?
Provide a succinct answer. 0.73. What is the ratio of the Value added (current US$) in Nepal in 2004 to that in 2006?
Make the answer very short. 0.85. What is the ratio of the Value added (current US$) in Poland in 2004 to that in 2006?
Make the answer very short. 0.75. What is the ratio of the Value added (current US$) of Botswana in 2004 to that in 2007?
Provide a succinct answer. 0.73. What is the ratio of the Value added (current US$) in Lao PDR in 2004 to that in 2007?
Offer a very short reply. 0.58. What is the ratio of the Value added (current US$) in Nepal in 2004 to that in 2007?
Your answer should be compact. 0.76. What is the ratio of the Value added (current US$) in Poland in 2004 to that in 2007?
Your answer should be very brief. 0.61. What is the ratio of the Value added (current US$) of Botswana in 2004 to that in 2008?
Ensure brevity in your answer.  0.79. What is the ratio of the Value added (current US$) in Lao PDR in 2004 to that in 2008?
Ensure brevity in your answer.  0.44. What is the ratio of the Value added (current US$) in Nepal in 2004 to that in 2008?
Keep it short and to the point. 0.64. What is the ratio of the Value added (current US$) in Poland in 2004 to that in 2008?
Provide a succinct answer. 0.5. What is the ratio of the Value added (current US$) of Botswana in 2005 to that in 2006?
Make the answer very short. 0.92. What is the ratio of the Value added (current US$) in Lao PDR in 2005 to that in 2006?
Keep it short and to the point. 0.94. What is the ratio of the Value added (current US$) of Nepal in 2005 to that in 2006?
Provide a succinct answer. 0.94. What is the ratio of the Value added (current US$) of Poland in 2005 to that in 2006?
Provide a short and direct response. 0.86. What is the ratio of the Value added (current US$) in Botswana in 2005 to that in 2007?
Keep it short and to the point. 0.72. What is the ratio of the Value added (current US$) in Lao PDR in 2005 to that in 2007?
Provide a short and direct response. 0.75. What is the ratio of the Value added (current US$) of Nepal in 2005 to that in 2007?
Provide a short and direct response. 0.84. What is the ratio of the Value added (current US$) of Poland in 2005 to that in 2007?
Your response must be concise. 0.7. What is the ratio of the Value added (current US$) in Botswana in 2005 to that in 2008?
Your response must be concise. 0.78. What is the ratio of the Value added (current US$) in Lao PDR in 2005 to that in 2008?
Provide a succinct answer. 0.56. What is the ratio of the Value added (current US$) of Nepal in 2005 to that in 2008?
Make the answer very short. 0.7. What is the ratio of the Value added (current US$) of Poland in 2005 to that in 2008?
Provide a short and direct response. 0.57. What is the ratio of the Value added (current US$) of Botswana in 2006 to that in 2007?
Make the answer very short. 0.78. What is the ratio of the Value added (current US$) of Lao PDR in 2006 to that in 2007?
Keep it short and to the point. 0.8. What is the ratio of the Value added (current US$) in Nepal in 2006 to that in 2007?
Give a very brief answer. 0.89. What is the ratio of the Value added (current US$) of Poland in 2006 to that in 2007?
Make the answer very short. 0.81. What is the ratio of the Value added (current US$) in Botswana in 2006 to that in 2008?
Ensure brevity in your answer.  0.85. What is the ratio of the Value added (current US$) in Lao PDR in 2006 to that in 2008?
Provide a succinct answer. 0.6. What is the ratio of the Value added (current US$) of Nepal in 2006 to that in 2008?
Your answer should be very brief. 0.75. What is the ratio of the Value added (current US$) in Poland in 2006 to that in 2008?
Your answer should be very brief. 0.66. What is the ratio of the Value added (current US$) in Botswana in 2007 to that in 2008?
Provide a succinct answer. 1.09. What is the ratio of the Value added (current US$) of Lao PDR in 2007 to that in 2008?
Offer a terse response. 0.75. What is the ratio of the Value added (current US$) of Nepal in 2007 to that in 2008?
Offer a terse response. 0.84. What is the ratio of the Value added (current US$) in Poland in 2007 to that in 2008?
Your response must be concise. 0.82. What is the difference between the highest and the second highest Value added (current US$) in Botswana?
Your answer should be very brief. 5.85e+07. What is the difference between the highest and the second highest Value added (current US$) in Lao PDR?
Provide a short and direct response. 1.13e+08. What is the difference between the highest and the second highest Value added (current US$) in Nepal?
Your answer should be compact. 1.39e+08. What is the difference between the highest and the second highest Value added (current US$) of Poland?
Make the answer very short. 1.57e+1. What is the difference between the highest and the lowest Value added (current US$) of Botswana?
Ensure brevity in your answer.  3.56e+08. What is the difference between the highest and the lowest Value added (current US$) of Lao PDR?
Ensure brevity in your answer.  3.08e+08. What is the difference between the highest and the lowest Value added (current US$) in Nepal?
Offer a very short reply. 3.83e+08. What is the difference between the highest and the lowest Value added (current US$) in Poland?
Offer a very short reply. 5.74e+1. 